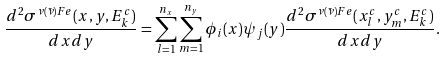<formula> <loc_0><loc_0><loc_500><loc_500>\frac { d ^ { 2 } \sigma ^ { \nu ( \bar { \nu } ) F e } ( x , y , E ^ { c } _ { k } ) } { d x d y } = \sum _ { l = 1 } ^ { n _ { x } } \sum _ { m = 1 } ^ { n _ { y } } \phi _ { i } ( x ) \psi _ { j } ( y ) \frac { d ^ { 2 } \sigma ^ { \nu ( \bar { \nu } ) F e } ( x _ { l } ^ { c } , y _ { m } ^ { c } , E ^ { c } _ { k } ) } { d x d y } .</formula> 